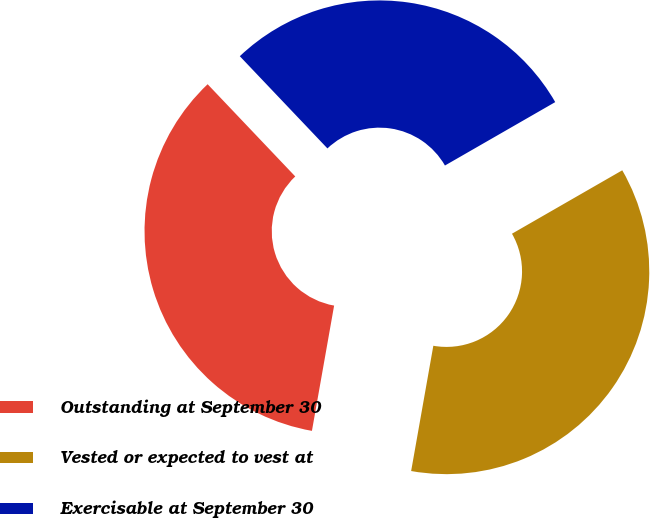Convert chart to OTSL. <chart><loc_0><loc_0><loc_500><loc_500><pie_chart><fcel>Outstanding at September 30<fcel>Vested or expected to vest at<fcel>Exercisable at September 30<nl><fcel>35.12%<fcel>36.1%<fcel>28.79%<nl></chart> 